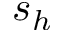<formula> <loc_0><loc_0><loc_500><loc_500>s _ { h }</formula> 